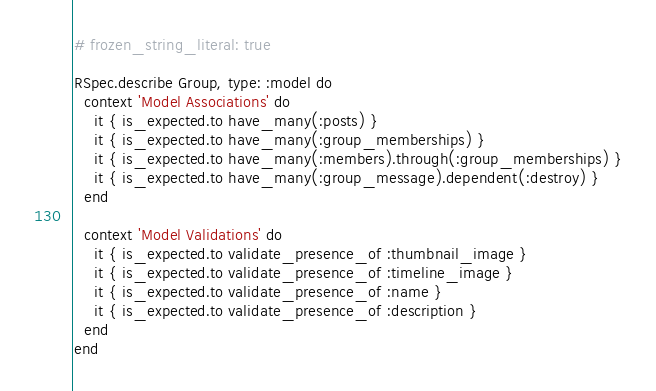<code> <loc_0><loc_0><loc_500><loc_500><_Ruby_># frozen_string_literal: true

RSpec.describe Group, type: :model do
  context 'Model Associations' do
    it { is_expected.to have_many(:posts) }
    it { is_expected.to have_many(:group_memberships) }
    it { is_expected.to have_many(:members).through(:group_memberships) }
    it { is_expected.to have_many(:group_message).dependent(:destroy) }
  end

  context 'Model Validations' do
    it { is_expected.to validate_presence_of :thumbnail_image }
    it { is_expected.to validate_presence_of :timeline_image }
    it { is_expected.to validate_presence_of :name }
    it { is_expected.to validate_presence_of :description }
  end
end
</code> 